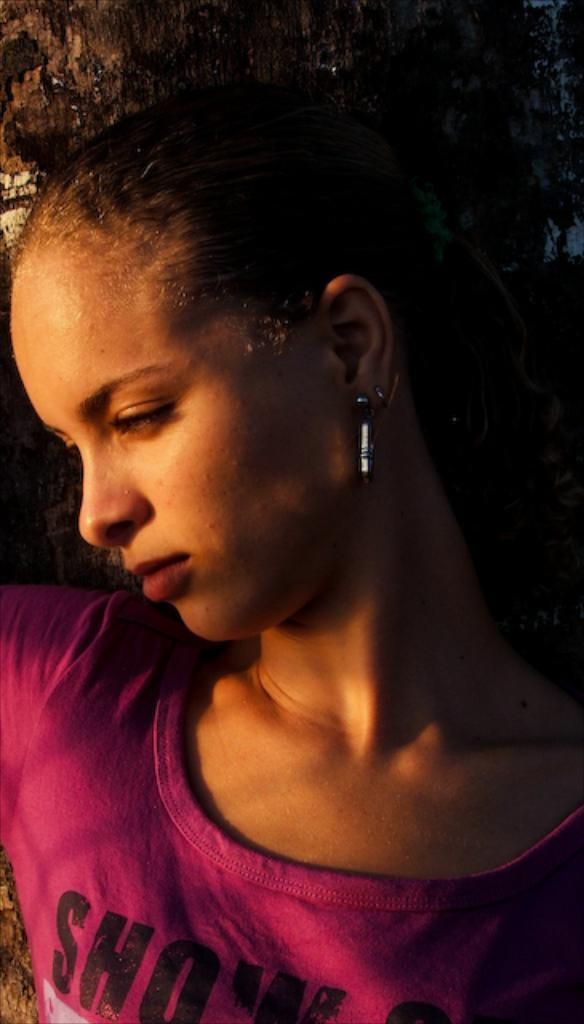What is the main subject in the foreground of the image? There is a woman in the foreground of the image. What can be seen in the background of the image? There is a tree in the background of the image. What type of zephyr can be seen blowing through the woman's hair in the image? There is no zephyr present in the image, and the woman's hair is not being blown by any wind. What appliance is visible in the image? There is no appliance present in the image. 